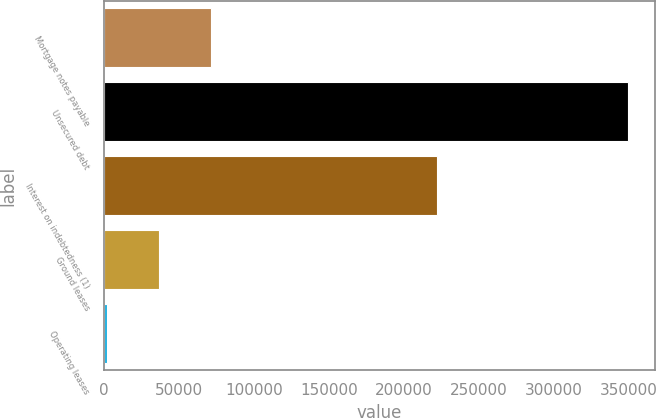<chart> <loc_0><loc_0><loc_500><loc_500><bar_chart><fcel>Mortgage notes payable<fcel>Unsecured debt<fcel>Interest on indebtedness (1)<fcel>Ground leases<fcel>Operating leases<nl><fcel>71356<fcel>350000<fcel>221917<fcel>36525.5<fcel>1695<nl></chart> 